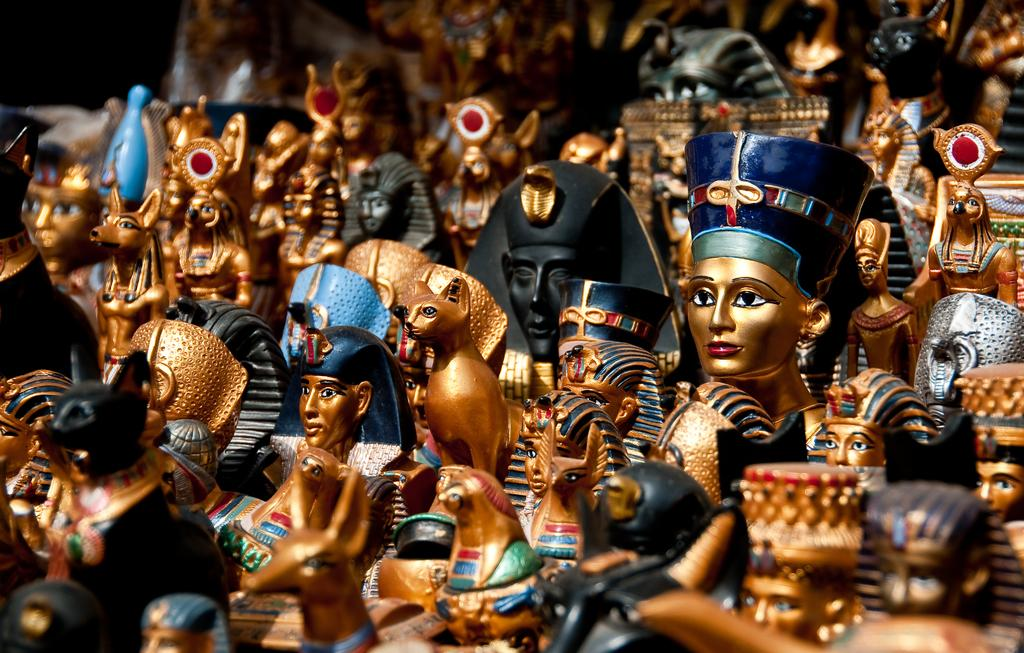What is the main subject of the image? The main subject of the image is many idols. In which direction are the idols facing? The idols are facing towards the left side. What type of lift is present in the image? There is no lift present in the image; it features many idols facing towards the left side. What type of battle is depicted in the image? There is no battle depicted in the image; it features many idols facing towards the left side. 